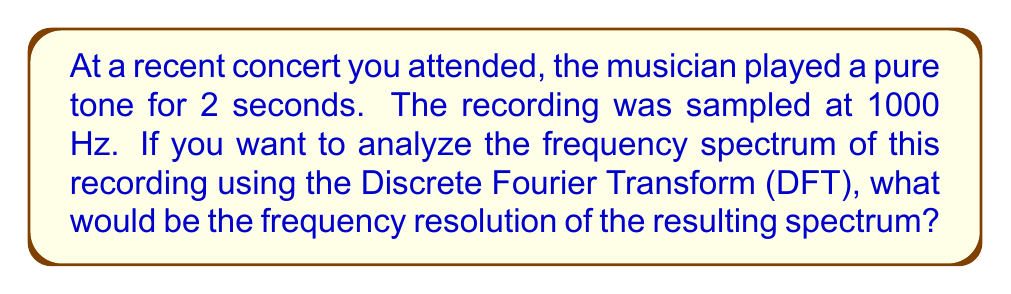Solve this math problem. To solve this problem, we need to follow these steps:

1) First, recall that the frequency resolution $\Delta f$ in a DFT is given by:

   $$\Delta f = \frac{f_s}{N}$$

   where $f_s$ is the sampling frequency and $N$ is the total number of samples.

2) We're given that the sampling frequency $f_s = 1000$ Hz.

3) To find $N$, we need to calculate the total number of samples in the 2-second recording:

   $$N = f_s \times \text{duration} = 1000 \text{ Hz} \times 2 \text{ s} = 2000 \text{ samples}$$

4) Now we can substitute these values into our frequency resolution formula:

   $$\Delta f = \frac{f_s}{N} = \frac{1000 \text{ Hz}}{2000} = 0.5 \text{ Hz}$$

Therefore, the frequency resolution of the resulting spectrum would be 0.5 Hz.

This means that in the frequency spectrum, adjacent frequency bins will be separated by 0.5 Hz. This resolution allows you to distinguish between frequencies that are at least 0.5 Hz apart in the recorded signal.
Answer: 0.5 Hz 